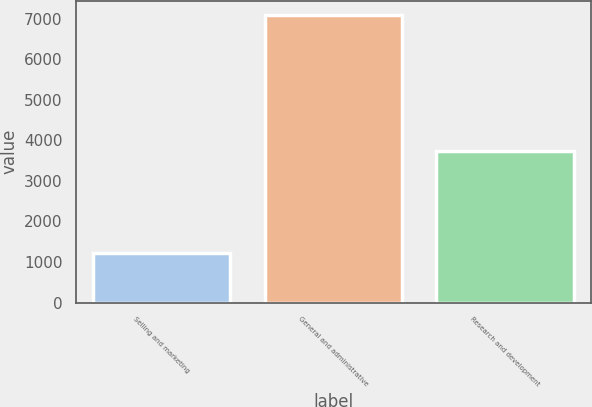Convert chart to OTSL. <chart><loc_0><loc_0><loc_500><loc_500><bar_chart><fcel>Selling and marketing<fcel>General and administrative<fcel>Research and development<nl><fcel>1232<fcel>7080<fcel>3735<nl></chart> 